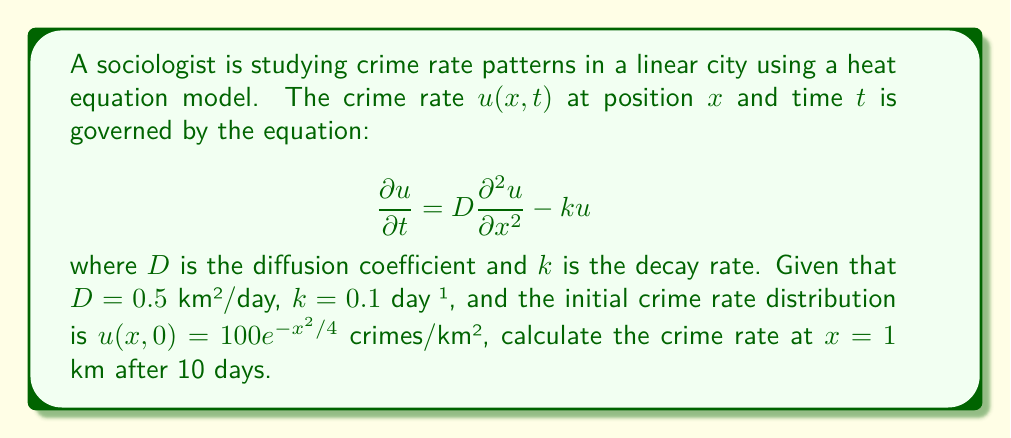Could you help me with this problem? To solve this problem, we need to use the solution to the heat equation with decay. The general solution for this type of equation is:

$$u(x,t) = \frac{1}{\sqrt{4\pi Dt}} \int_{-\infty}^{\infty} u(\xi,0) e^{-\frac{(x-\xi)^2}{4Dt}} e^{-kt} d\xi$$

Where $u(\xi,0)$ is the initial condition.

Given:
- $D = 0.5$ km²/day
- $k = 0.1$ day⁻¹
- $u(x,0) = 100e^{-x^2/4}$ crimes/km²
- We want to find $u(1,10)$

Step 1: Substitute the values into the solution equation:

$$u(1,10) = \frac{1}{\sqrt{4\pi(0.5)(10)}} \int_{-\infty}^{\infty} 100e^{-\xi^2/4} e^{-\frac{(1-\xi)^2}{4(0.5)(10)}} e^{-(0.1)(10)} d\xi$$

Step 2: Simplify the constants:

$$u(1,10) = \frac{100e^{-1}}{\sqrt{20\pi}} \int_{-\infty}^{\infty} e^{-\xi^2/4} e^{-\frac{(1-\xi)^2}{20}} d\xi$$

Step 3: Combine the exponents in the integrand:

$$u(1,10) = \frac{100e^{-1}}{\sqrt{20\pi}} \int_{-\infty}^{\infty} e^{-\frac{\xi^2}{4} - \frac{1-2\xi+\xi^2}{20}} d\xi$$

$$= \frac{100e^{-1}}{\sqrt{20\pi}} \int_{-\infty}^{\infty} e^{-\frac{5\xi^2}{20} - \frac{\xi^2}{20} + \frac{\xi}{10} - \frac{1}{20}} d\xi$$

$$= \frac{100e^{-1}}{\sqrt{20\pi}} e^{-\frac{1}{20}} \int_{-\infty}^{\infty} e^{-\frac{3\xi^2}{10} + \frac{\xi}{10}} d\xi$$

Step 4: Complete the square in the exponent:

$$u(1,10) = \frac{100e^{-1}}{\sqrt{20\pi}} e^{-\frac{1}{20}} \int_{-\infty}^{\infty} e^{-\frac{3}{10}(\xi^2 - \frac{\xi}{3} + \frac{1}{36}) + \frac{1}{120}} d\xi$$

$$= \frac{100e^{-1}}{\sqrt{20\pi}} e^{-\frac{1}{20} + \frac{1}{120}} \int_{-\infty}^{\infty} e^{-\frac{3}{10}(\xi - \frac{1}{6})^2} d\xi$$

Step 5: Evaluate the integral:

$$u(1,10) = \frac{100e^{-1}}{\sqrt{20\pi}} e^{-\frac{1}{20} + \frac{1}{120}} \sqrt{\frac{10\pi}{3}}$$

Step 6: Simplify:

$$u(1,10) = 100e^{-1} e^{-\frac{1}{20} + \frac{1}{120}} \sqrt{\frac{1}{6}} \approx 22.31$$
Answer: The crime rate at $x = 1$ km after 10 days is approximately 22.31 crimes/km². 